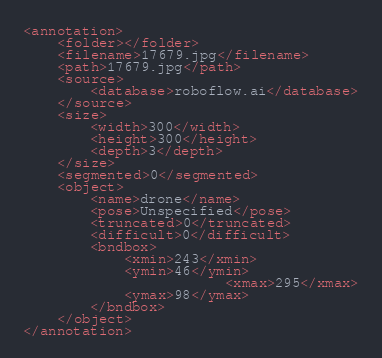Convert code to text. <code><loc_0><loc_0><loc_500><loc_500><_XML_><annotation>
	<folder></folder>
	<filename>17679.jpg</filename>
	<path>17679.jpg</path>
	<source>
		<database>roboflow.ai</database>
	</source>
	<size>
		<width>300</width>
		<height>300</height>
		<depth>3</depth>
	</size>
	<segmented>0</segmented>
	<object>
		<name>drone</name>
		<pose>Unspecified</pose>
		<truncated>0</truncated>
		<difficult>0</difficult>
		<bndbox>
			<xmin>243</xmin>
			<ymin>46</ymin>
                        <xmax>295</xmax>
			<ymax>98</ymax>
		</bndbox>
	</object>
</annotation>
</code> 